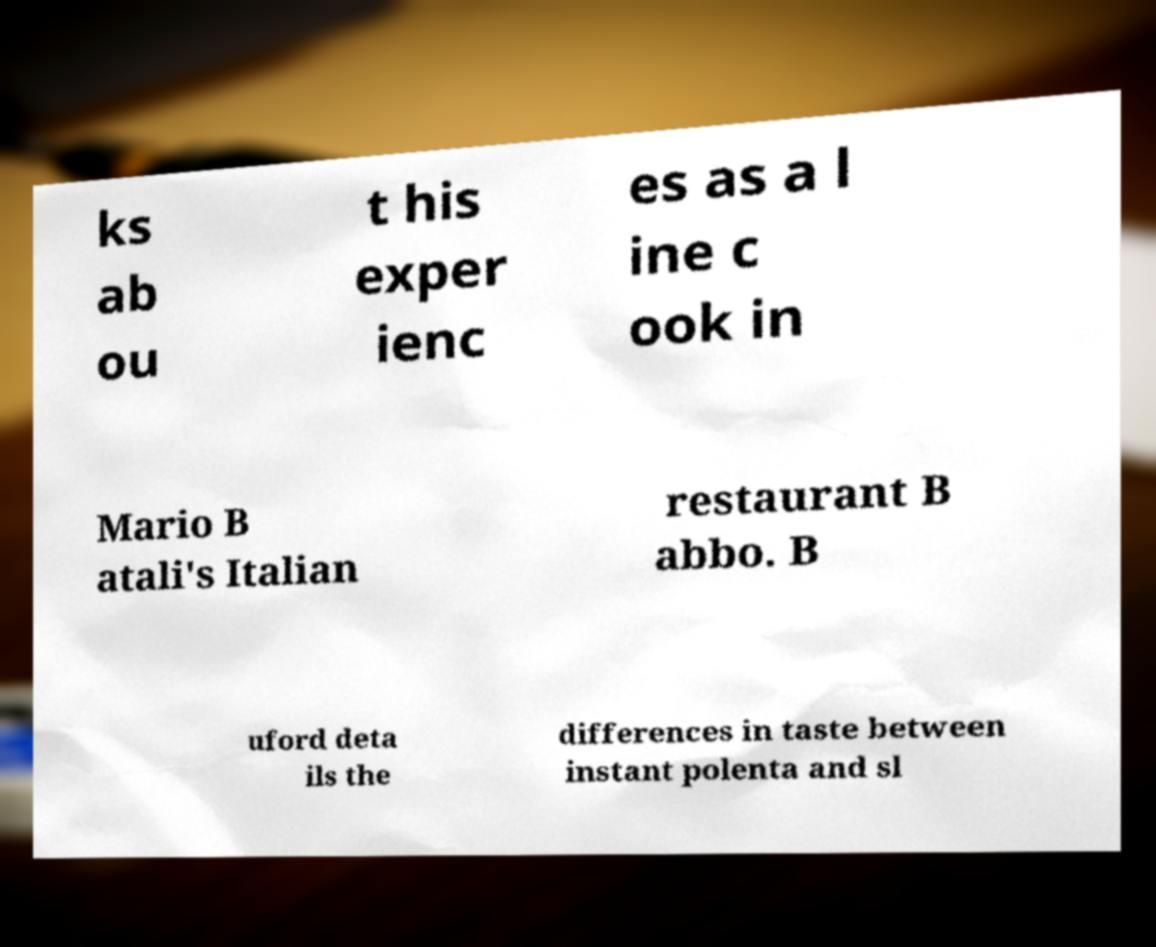Please identify and transcribe the text found in this image. ks ab ou t his exper ienc es as a l ine c ook in Mario B atali's Italian restaurant B abbo. B uford deta ils the differences in taste between instant polenta and sl 